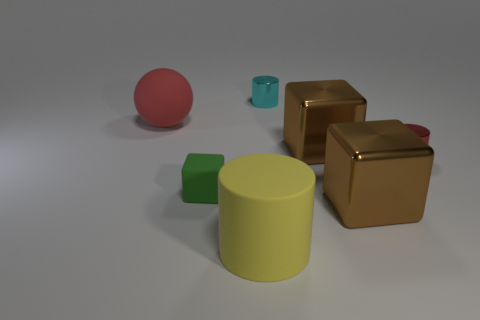Subtract all metallic cylinders. How many cylinders are left? 1 Add 1 small shiny objects. How many objects exist? 8 Subtract all balls. How many objects are left? 6 Subtract 2 cylinders. How many cylinders are left? 1 Add 4 green matte objects. How many green matte objects are left? 5 Add 4 large rubber cubes. How many large rubber cubes exist? 4 Subtract all brown blocks. How many blocks are left? 1 Subtract 0 blue spheres. How many objects are left? 7 Subtract all green blocks. Subtract all gray balls. How many blocks are left? 2 Subtract all green cubes. How many yellow cylinders are left? 1 